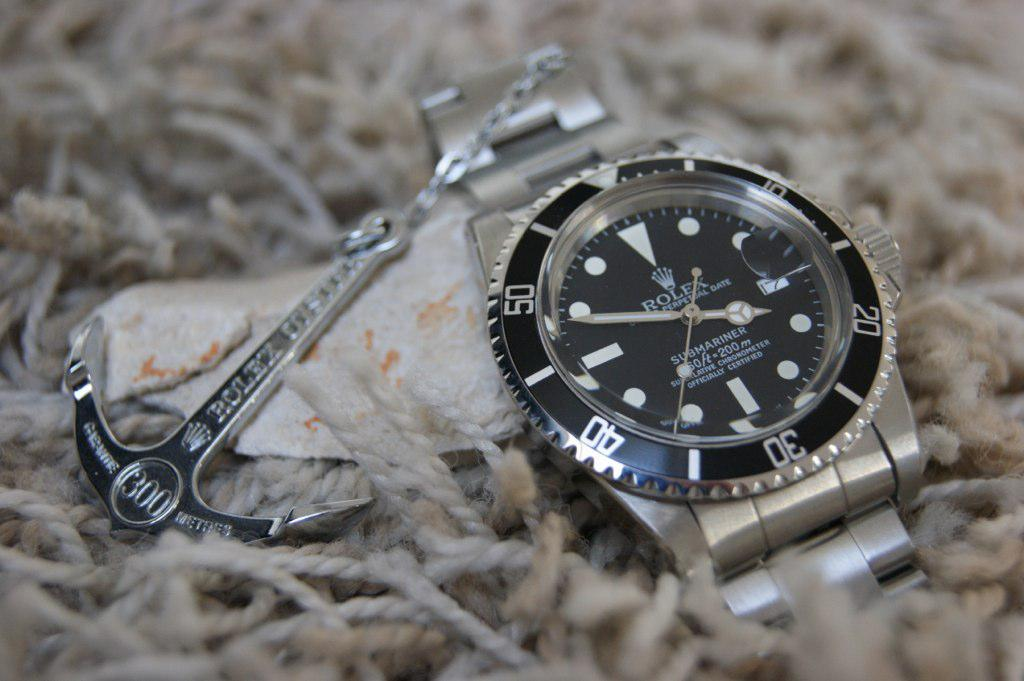Provide a one-sentence caption for the provided image. Silver and black watch for the brand named ROLEX. 